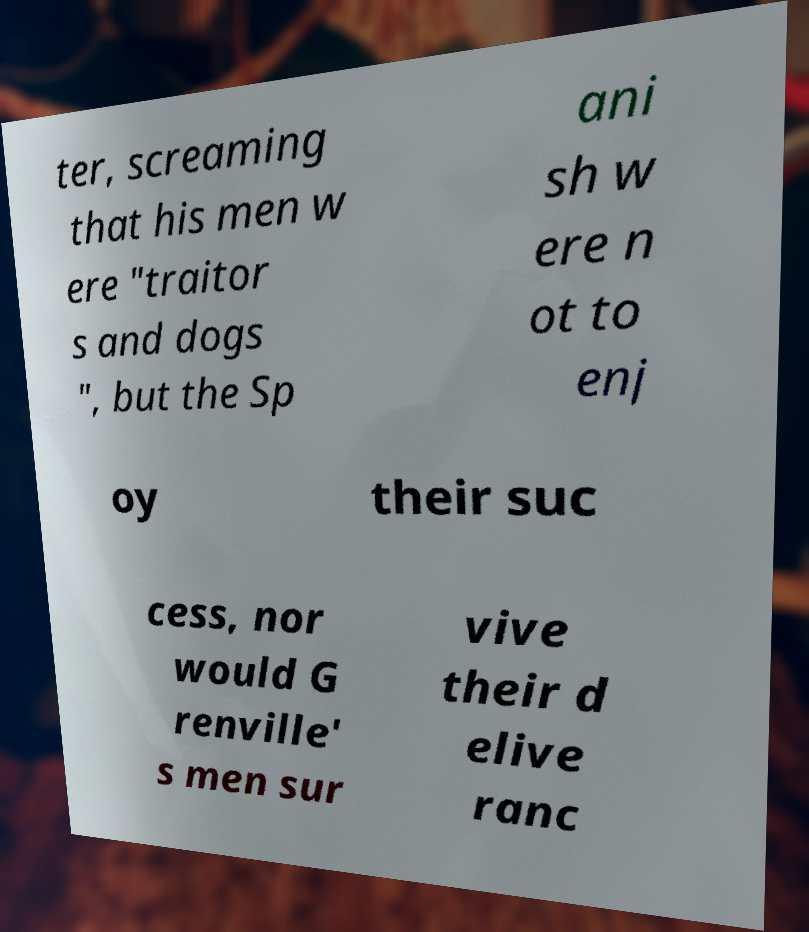Can you accurately transcribe the text from the provided image for me? ter, screaming that his men w ere "traitor s and dogs ", but the Sp ani sh w ere n ot to enj oy their suc cess, nor would G renville' s men sur vive their d elive ranc 